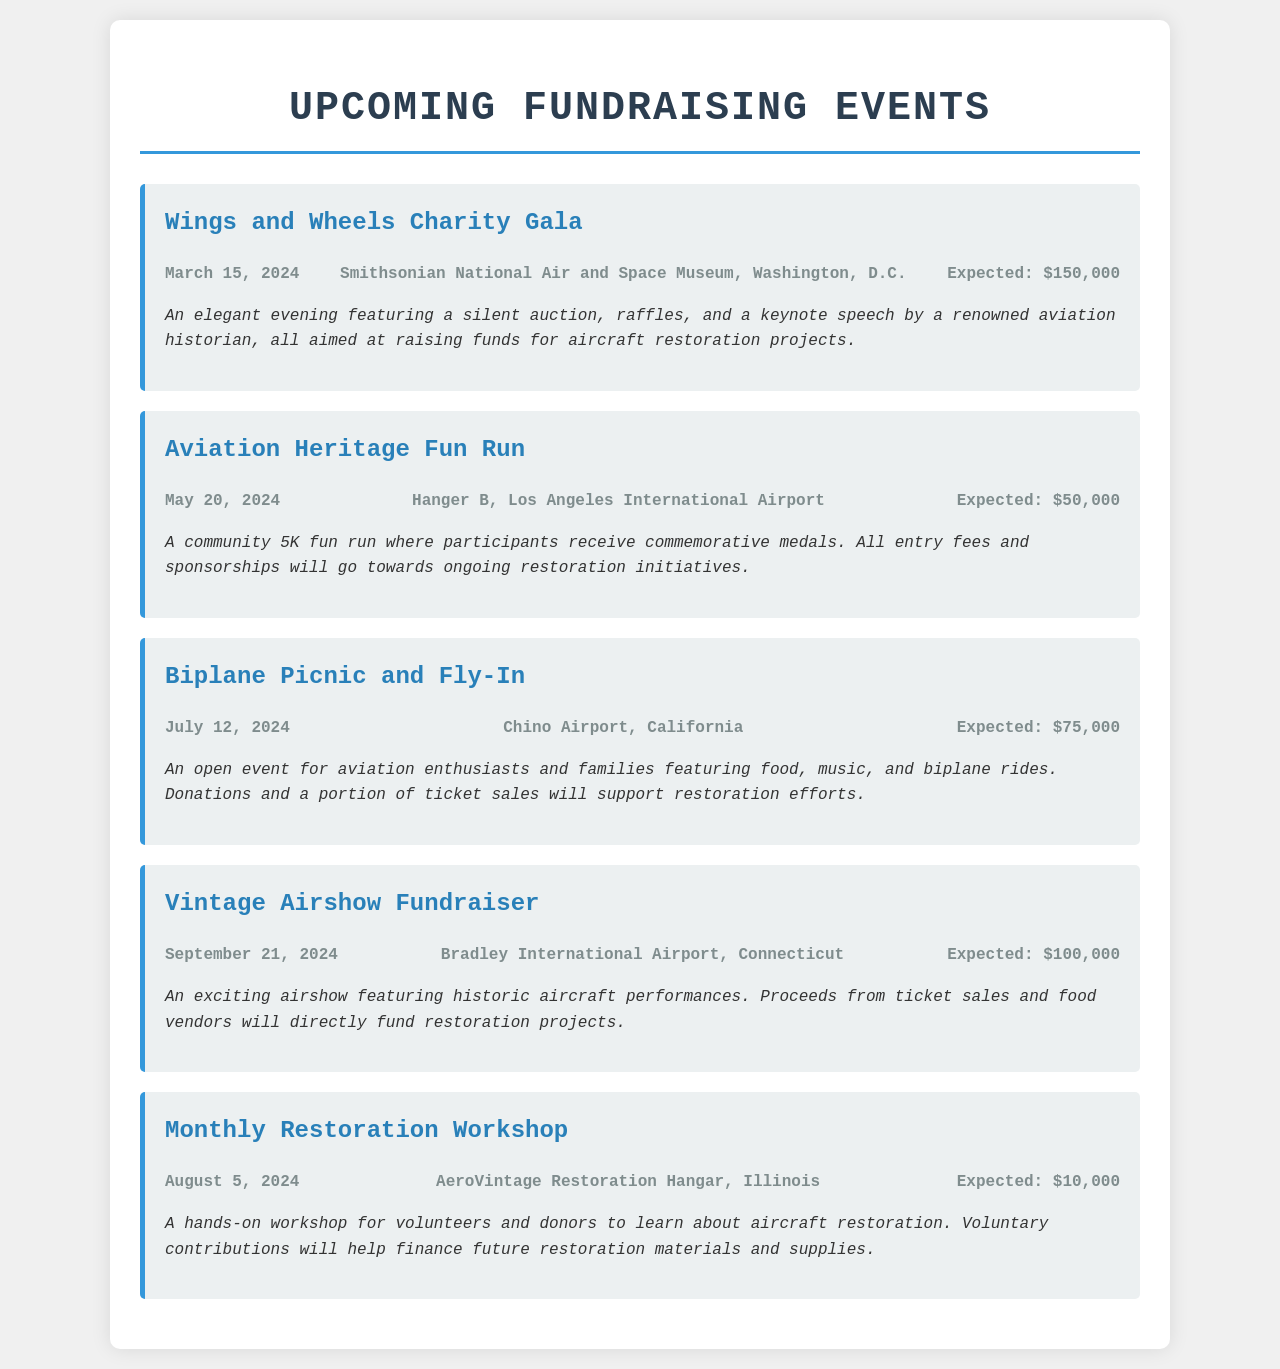What is the date of the Wings and Wheels Charity Gala? The date of the event is mentioned in the event details section for the Wings and Wheels Charity Gala.
Answer: March 15, 2024 Where is the Aviation Heritage Fun Run taking place? The location is specified in the event details section for the Aviation Heritage Fun Run.
Answer: Hanger B, Los Angeles International Airport What is the expected contribution from the Biplane Picnic and Fly-In? The expected contribution amount is given in the event details for the Biplane Picnic and Fly-In.
Answer: $75,000 What type of event is the Vintage Airshow Fundraiser? This question refers to the description provided under the Vintage Airshow Fundraiser event.
Answer: Airshow What will happen on August 5, 2024? The event scheduled for this date is defined in the document, referring to the Monthly Restoration Workshop.
Answer: Monthly Restoration Workshop How many fundraising events are listed in the document? The total number of events can be counted from the events mentioned in the document.
Answer: Five What is one activity included in the Wings and Wheels Charity Gala? The description mentions activities associated with the gala, such as a silent auction.
Answer: Silent auction What will the proceeds from the Vintage Airshow Fundraiser support? The document specifies that funds raised will go towards restoration projects.
Answer: Restoration projects Which event is expected to raise the least amount of money? By comparing the expected contributions listed in the document, the answer is identifiable.
Answer: Monthly Restoration Workshop 